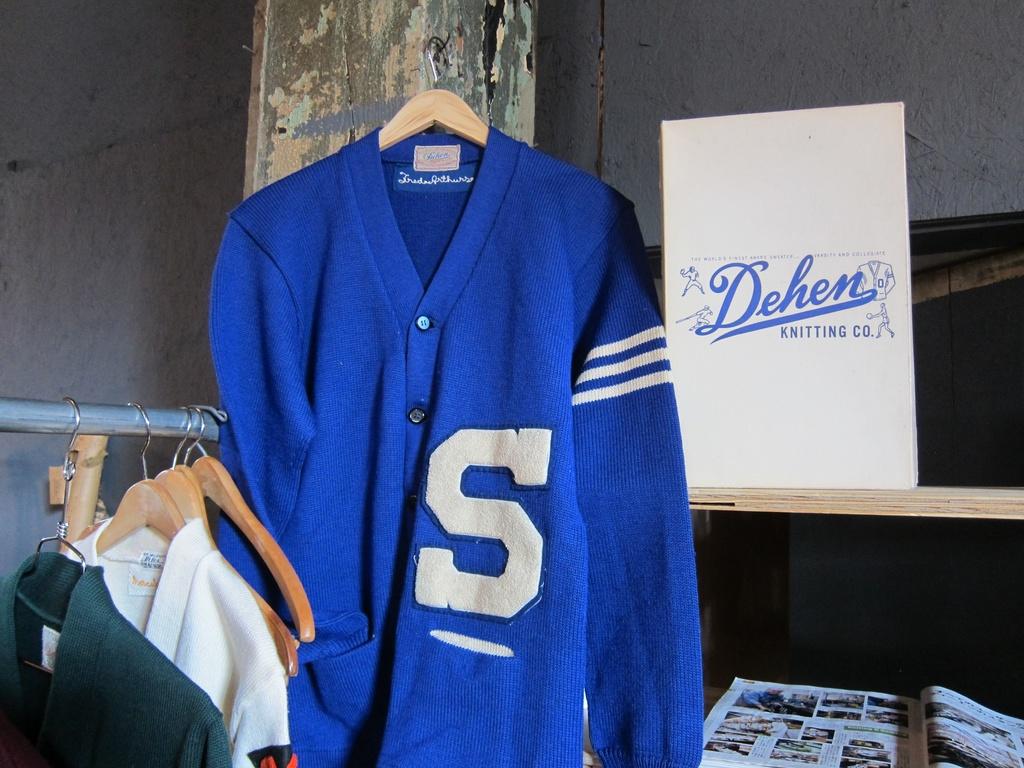What letter is on the jacker?
Your answer should be very brief. S. 